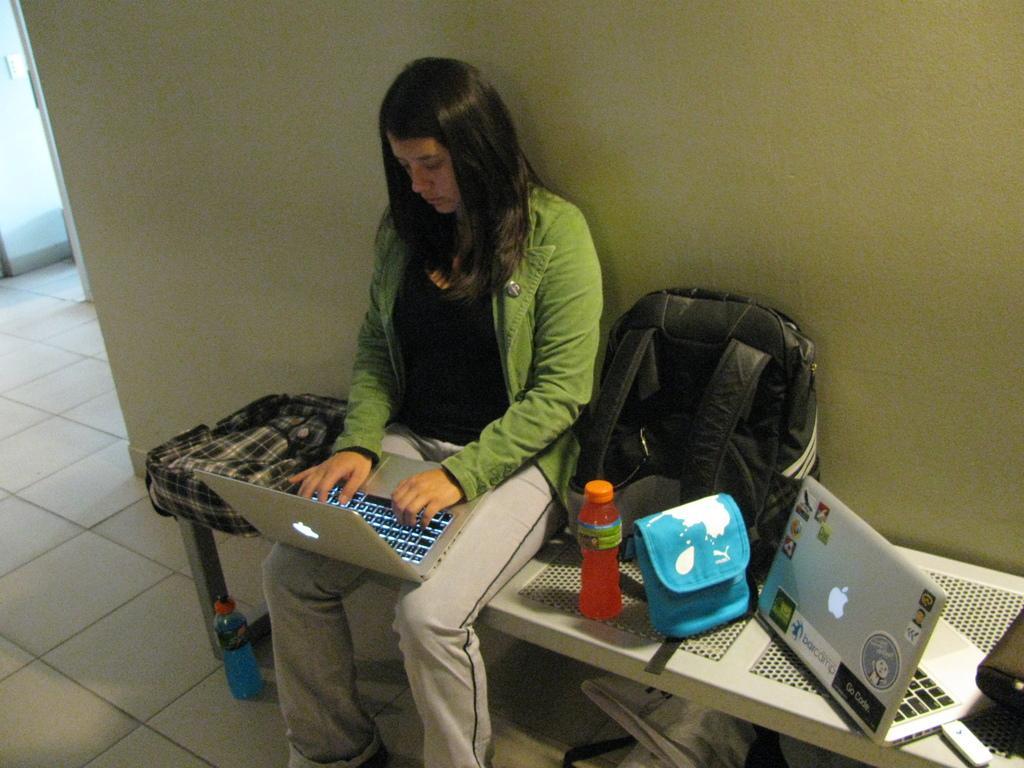Could you give a brief overview of what you see in this image? There is a woman sitting on a bench and operating a mac book and there is a bag,laptop,water bottle on the bench. 